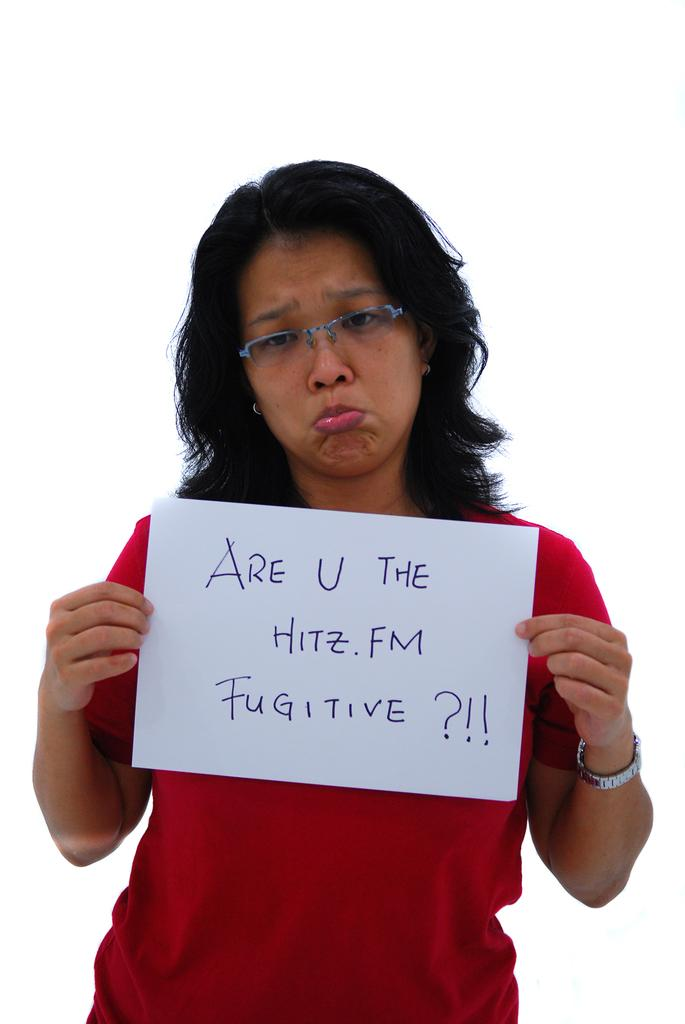<image>
Relay a brief, clear account of the picture shown. a women holding up a sign saying are you the hitz.fm fugitive 